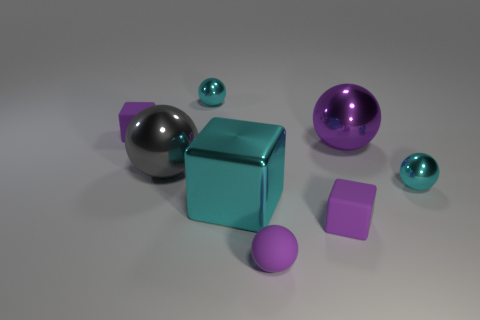How many large objects are either purple objects or shiny objects?
Make the answer very short. 3. The gray metal object has what shape?
Offer a very short reply. Sphere. The other ball that is the same color as the matte ball is what size?
Keep it short and to the point. Large. Are there any purple cubes made of the same material as the gray object?
Make the answer very short. No. Are there more cyan cubes than spheres?
Provide a short and direct response. No. Are the large cyan thing and the gray ball made of the same material?
Offer a terse response. Yes. What number of matte things are either large purple balls or small purple objects?
Offer a very short reply. 3. What is the color of the block that is the same size as the gray thing?
Your answer should be compact. Cyan. How many tiny things are the same shape as the large cyan metallic thing?
Your answer should be very brief. 2. How many blocks are either purple things or big cyan objects?
Ensure brevity in your answer.  3. 